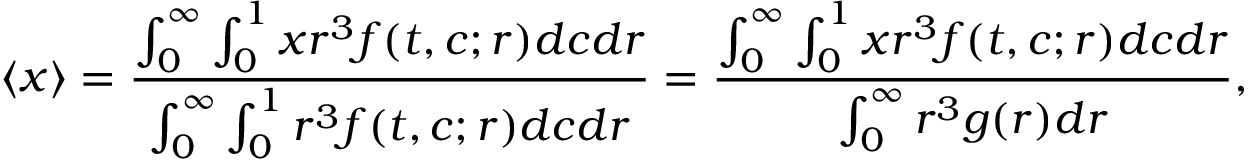<formula> <loc_0><loc_0><loc_500><loc_500>\langle x \rangle = \frac { \int _ { 0 } ^ { \infty } \int _ { 0 } ^ { 1 } x r ^ { 3 } f ( t , c ; r ) d c d r } { \int _ { 0 } ^ { \infty } \int _ { 0 } ^ { 1 } r ^ { 3 } f ( t , c ; r ) d c d r } = \frac { \int _ { 0 } ^ { \infty } \int _ { 0 } ^ { 1 } x r ^ { 3 } f ( t , c ; r ) d c d r } { \int _ { 0 } ^ { \infty } r ^ { 3 } g ( r ) d r } ,</formula> 